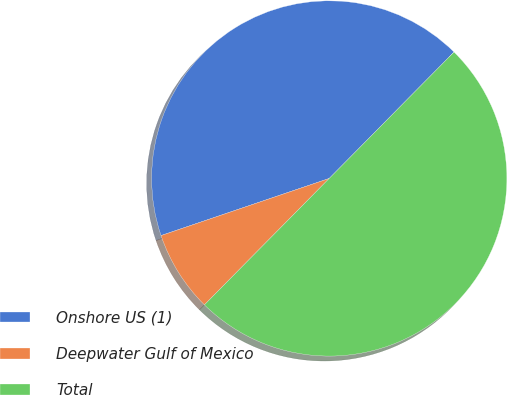Convert chart to OTSL. <chart><loc_0><loc_0><loc_500><loc_500><pie_chart><fcel>Onshore US (1)<fcel>Deepwater Gulf of Mexico<fcel>Total<nl><fcel>42.61%<fcel>7.39%<fcel>50.0%<nl></chart> 